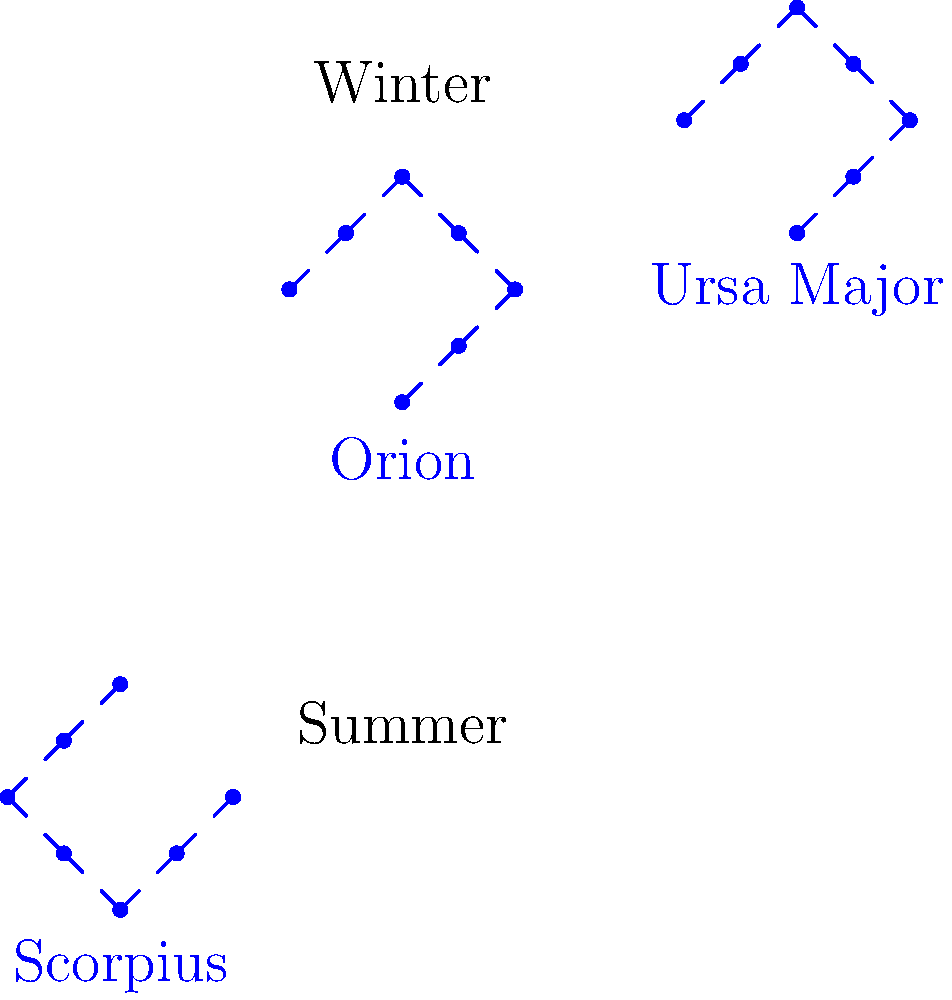As an advisor who values traditional methods, you understand the importance of celestial navigation throughout history. Which of the constellations shown in the diagram is typically associated with winter in the Northern Hemisphere and has been used for centuries as a reliable navigational aid? To answer this question, let's consider the following steps:

1. Examine the diagram: We see three constellations depicted - Orion, Ursa Major, and Scorpius.

2. Consider the seasonal labels: The diagram shows "Winter" at the top and "Summer" at the bottom.

3. Identify the winter constellation: Orion is positioned closer to the "Winter" label, indicating its prominence during winter months in the Northern Hemisphere.

4. Historical significance: Orion has been used for navigation throughout history due to its:
   a) Distinctive shape: Three bright stars form Orion's belt, making it easily recognizable.
   b) Visibility: It's one of the most prominent constellations in the winter sky.
   c) Position: It can be used to locate other stars and constellations.

5. Traditional methods: Using Orion for navigation aligns with traditional celestial navigation techniques, which have been relied upon for centuries before the advent of modern technology.

6. Consistency with the advisor's perspective: As an advisor who values traditional methods, recognizing Orion's historical importance in navigation would be in line with your expertise.

Therefore, Orion is the constellation that fits the criteria described in the question.
Answer: Orion 